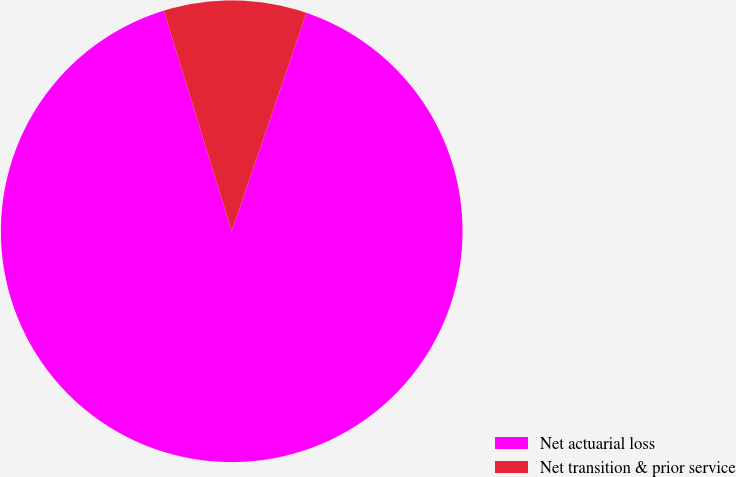<chart> <loc_0><loc_0><loc_500><loc_500><pie_chart><fcel>Net actuarial loss<fcel>Net transition & prior service<nl><fcel>90.0%<fcel>10.0%<nl></chart> 